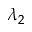Convert formula to latex. <formula><loc_0><loc_0><loc_500><loc_500>\lambda _ { 2 }</formula> 